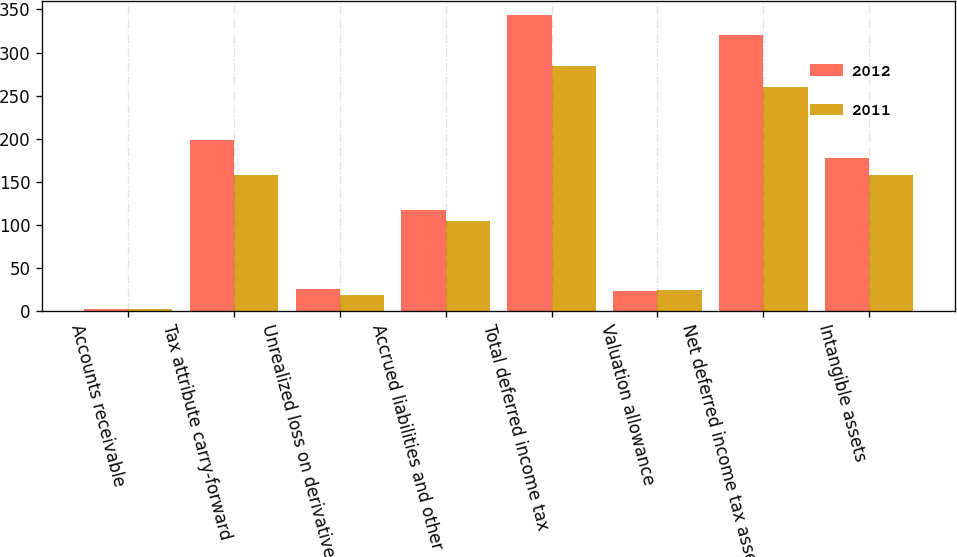Convert chart to OTSL. <chart><loc_0><loc_0><loc_500><loc_500><stacked_bar_chart><ecel><fcel>Accounts receivable<fcel>Tax attribute carry-forward<fcel>Unrealized loss on derivatives<fcel>Accrued liabilities and other<fcel>Total deferred income tax<fcel>Valuation allowance<fcel>Net deferred income tax assets<fcel>Intangible assets<nl><fcel>2012<fcel>2<fcel>198<fcel>26<fcel>117<fcel>343<fcel>23<fcel>320<fcel>178<nl><fcel>2011<fcel>2<fcel>158<fcel>19<fcel>105<fcel>284<fcel>24<fcel>260<fcel>158<nl></chart> 